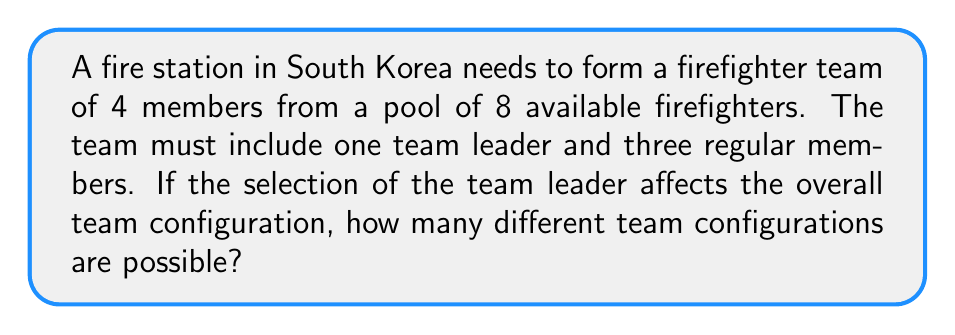Give your solution to this math problem. Let's approach this problem step-by-step using permutation groups:

1) First, we need to select the team leader. There are 8 choices for this position.

2) After selecting the team leader, we have 7 firefighters left to choose from for the remaining 3 positions.

3) This scenario can be modeled as a permutation with repetition not allowed. The order of selection matters because each position in the team might have specific responsibilities.

4) The number of possible configurations can be calculated using the permutation formula:

   $$P(n,r) = \frac{n!}{(n-r)!}$$

   Where $n$ is the total number of items to choose from, and $r$ is the number of items being chosen.

5) For selecting the 3 regular members after the leader has been chosen:

   $$P(7,3) = \frac{7!}{(7-3)!} = \frac{7!}{4!}$$

6) Calculating this:

   $$\frac{7!}{4!} = \frac{7 \times 6 \times 5 \times 4!}{4!} = 7 \times 6 \times 5 = 210$$

7) Since we have 8 choices for the leader, and for each leader choice we have 210 ways to arrange the other 3 members, we multiply:

   $$8 \times 210 = 1,680$$

Therefore, there are 1,680 possible team configurations.
Answer: 1,680 possible team configurations 